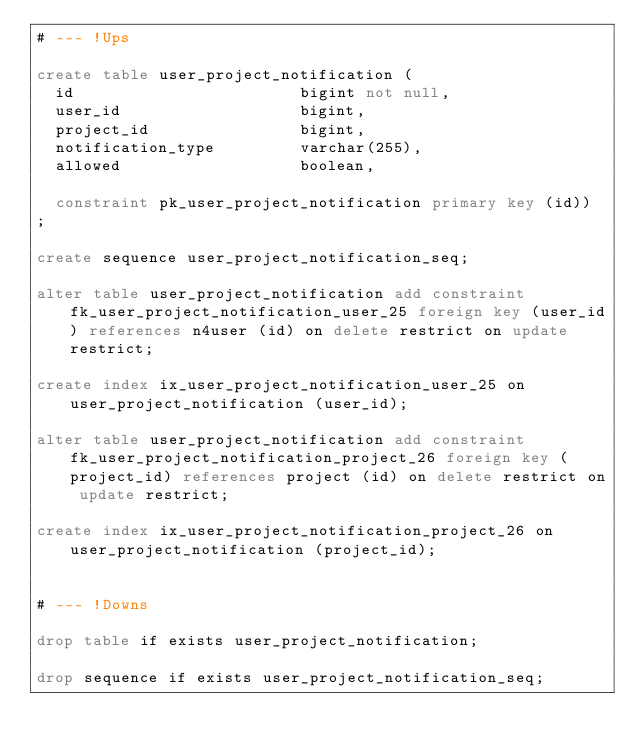<code> <loc_0><loc_0><loc_500><loc_500><_SQL_># --- !Ups

create table user_project_notification (
  id                        bigint not null,
  user_id                   bigint,
  project_id                bigint,
  notification_type         varchar(255),
  allowed                   boolean,

  constraint pk_user_project_notification primary key (id))
;

create sequence user_project_notification_seq;

alter table user_project_notification add constraint fk_user_project_notification_user_25 foreign key (user_id) references n4user (id) on delete restrict on update restrict;

create index ix_user_project_notification_user_25 on user_project_notification (user_id);

alter table user_project_notification add constraint fk_user_project_notification_project_26 foreign key (project_id) references project (id) on delete restrict on update restrict;

create index ix_user_project_notification_project_26 on user_project_notification (project_id);


# --- !Downs

drop table if exists user_project_notification;

drop sequence if exists user_project_notification_seq;
</code> 